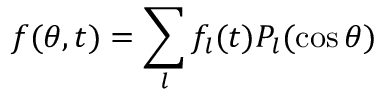Convert formula to latex. <formula><loc_0><loc_0><loc_500><loc_500>f ( \theta , t ) = \sum _ { l } f _ { l } ( t ) P _ { l } ( \cos \theta )</formula> 